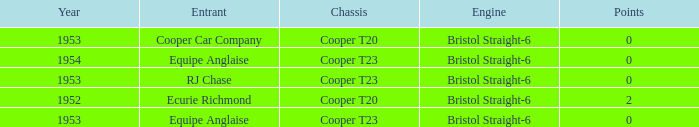Which of the biggest points numbers had a year more recent than 1953? 0.0. 